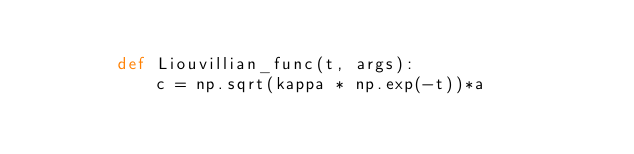<code> <loc_0><loc_0><loc_500><loc_500><_Python_>
        def Liouvillian_func(t, args):
            c = np.sqrt(kappa * np.exp(-t))*a</code> 